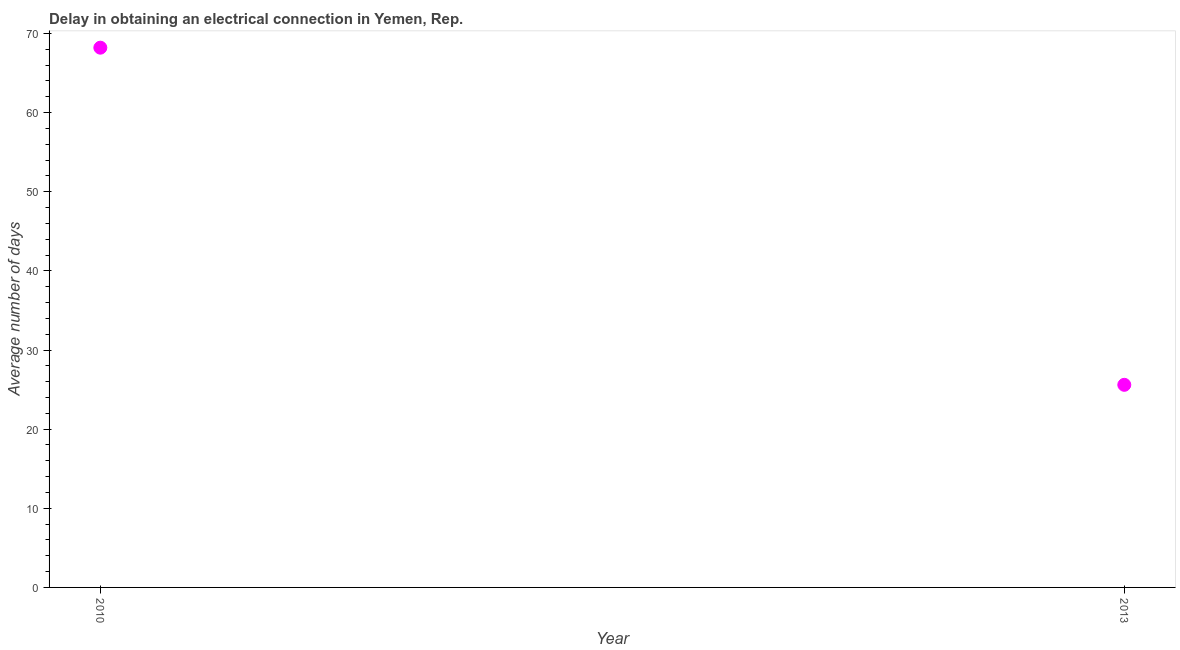What is the dalay in electrical connection in 2010?
Give a very brief answer. 68.2. Across all years, what is the maximum dalay in electrical connection?
Give a very brief answer. 68.2. Across all years, what is the minimum dalay in electrical connection?
Give a very brief answer. 25.6. What is the sum of the dalay in electrical connection?
Provide a succinct answer. 93.8. What is the difference between the dalay in electrical connection in 2010 and 2013?
Offer a terse response. 42.6. What is the average dalay in electrical connection per year?
Your answer should be very brief. 46.9. What is the median dalay in electrical connection?
Your response must be concise. 46.9. In how many years, is the dalay in electrical connection greater than 28 days?
Give a very brief answer. 1. Do a majority of the years between 2013 and 2010 (inclusive) have dalay in electrical connection greater than 62 days?
Give a very brief answer. No. What is the ratio of the dalay in electrical connection in 2010 to that in 2013?
Give a very brief answer. 2.66. In how many years, is the dalay in electrical connection greater than the average dalay in electrical connection taken over all years?
Make the answer very short. 1. Does the dalay in electrical connection monotonically increase over the years?
Offer a very short reply. No. How many dotlines are there?
Provide a short and direct response. 1. How many years are there in the graph?
Offer a terse response. 2. What is the title of the graph?
Make the answer very short. Delay in obtaining an electrical connection in Yemen, Rep. What is the label or title of the X-axis?
Keep it short and to the point. Year. What is the label or title of the Y-axis?
Give a very brief answer. Average number of days. What is the Average number of days in 2010?
Make the answer very short. 68.2. What is the Average number of days in 2013?
Your answer should be very brief. 25.6. What is the difference between the Average number of days in 2010 and 2013?
Your response must be concise. 42.6. What is the ratio of the Average number of days in 2010 to that in 2013?
Your answer should be very brief. 2.66. 